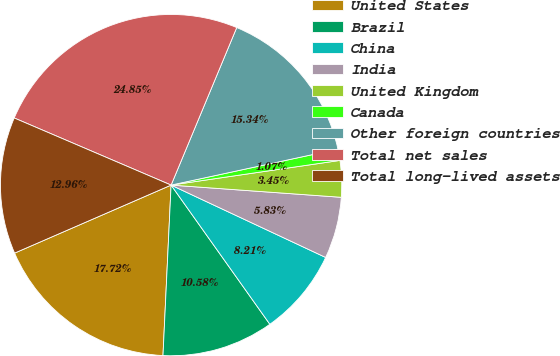Convert chart to OTSL. <chart><loc_0><loc_0><loc_500><loc_500><pie_chart><fcel>United States<fcel>Brazil<fcel>China<fcel>India<fcel>United Kingdom<fcel>Canada<fcel>Other foreign countries<fcel>Total net sales<fcel>Total long-lived assets<nl><fcel>17.72%<fcel>10.58%<fcel>8.21%<fcel>5.83%<fcel>3.45%<fcel>1.07%<fcel>15.34%<fcel>24.85%<fcel>12.96%<nl></chart> 